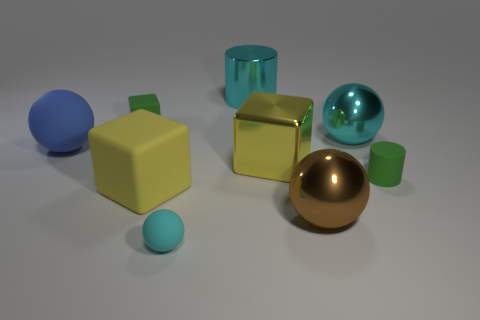Subtract all large yellow blocks. How many blocks are left? 1 Subtract all green cylinders. How many cylinders are left? 1 Subtract all cylinders. How many objects are left? 7 Subtract all gray cylinders. How many gray spheres are left? 0 Subtract all small green rubber cubes. Subtract all large red cubes. How many objects are left? 8 Add 6 large cyan cylinders. How many large cyan cylinders are left? 7 Add 1 tiny green rubber blocks. How many tiny green rubber blocks exist? 2 Subtract 0 blue cubes. How many objects are left? 9 Subtract 1 cylinders. How many cylinders are left? 1 Subtract all green cubes. Subtract all red spheres. How many cubes are left? 2 